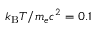Convert formula to latex. <formula><loc_0><loc_0><loc_500><loc_500>k _ { B } T / m _ { e } c ^ { 2 } = 0 . 1</formula> 